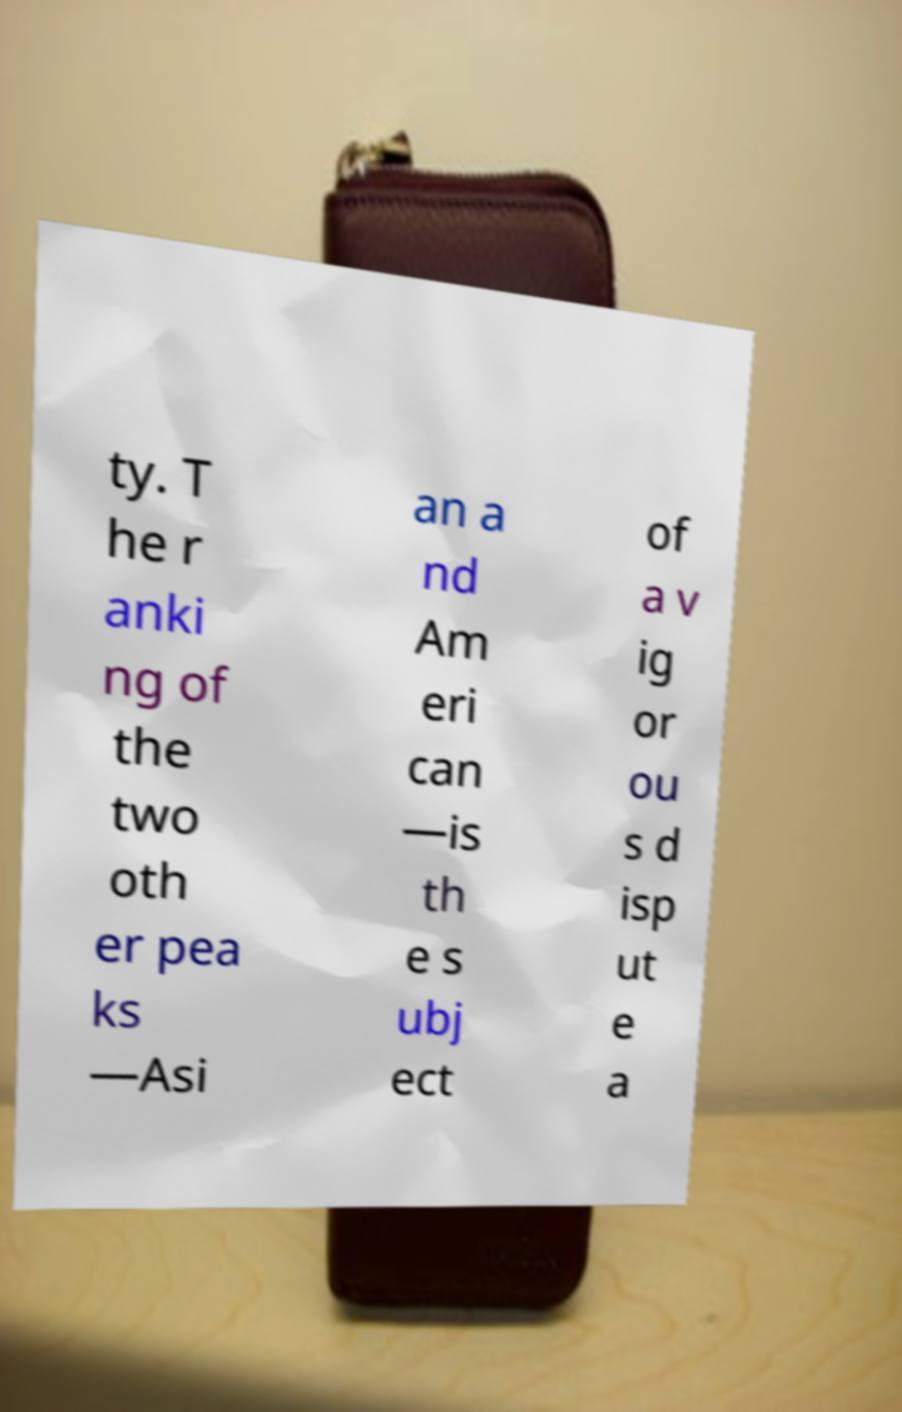Please read and relay the text visible in this image. What does it say? ty. T he r anki ng of the two oth er pea ks —Asi an a nd Am eri can —is th e s ubj ect of a v ig or ou s d isp ut e a 